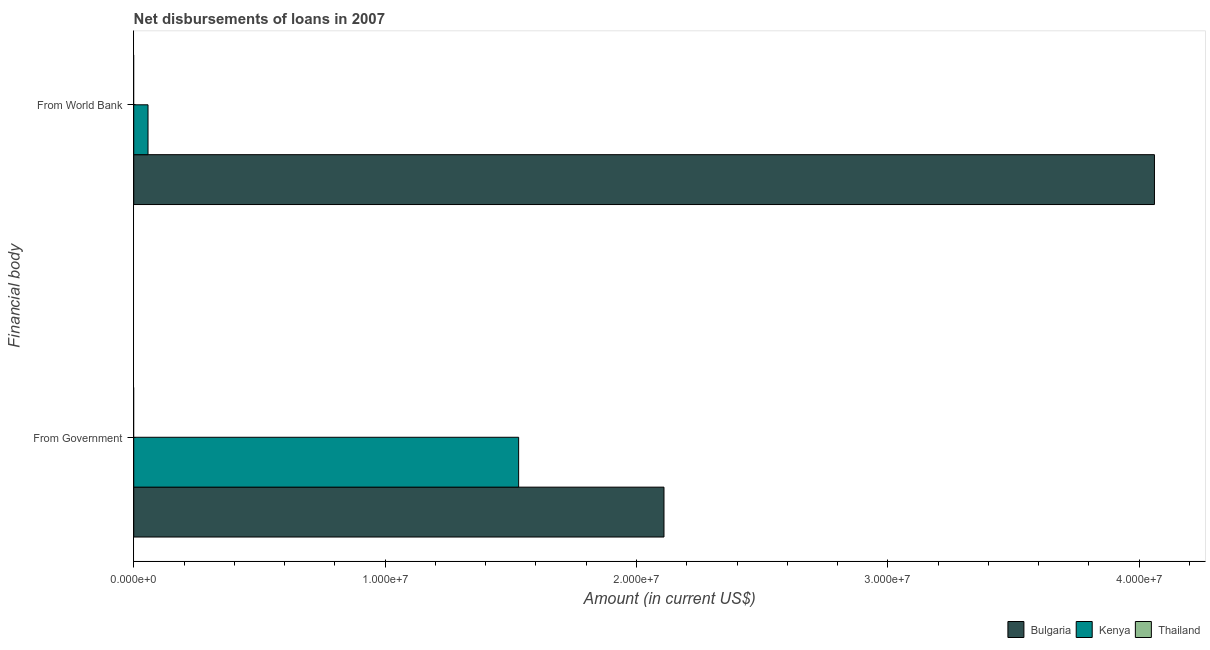How many groups of bars are there?
Make the answer very short. 2. Are the number of bars per tick equal to the number of legend labels?
Your answer should be very brief. No. Are the number of bars on each tick of the Y-axis equal?
Provide a short and direct response. Yes. What is the label of the 2nd group of bars from the top?
Your answer should be compact. From Government. What is the net disbursements of loan from government in Bulgaria?
Give a very brief answer. 2.11e+07. Across all countries, what is the maximum net disbursements of loan from government?
Give a very brief answer. 2.11e+07. What is the total net disbursements of loan from government in the graph?
Provide a short and direct response. 3.64e+07. What is the difference between the net disbursements of loan from world bank in Kenya and that in Bulgaria?
Offer a terse response. -4.00e+07. What is the difference between the net disbursements of loan from government in Bulgaria and the net disbursements of loan from world bank in Kenya?
Your answer should be compact. 2.05e+07. What is the average net disbursements of loan from world bank per country?
Provide a short and direct response. 1.37e+07. What is the difference between the net disbursements of loan from government and net disbursements of loan from world bank in Bulgaria?
Your answer should be very brief. -1.95e+07. In how many countries, is the net disbursements of loan from world bank greater than 2000000 US$?
Provide a succinct answer. 1. What is the ratio of the net disbursements of loan from government in Kenya to that in Bulgaria?
Give a very brief answer. 0.73. Is the net disbursements of loan from government in Bulgaria less than that in Kenya?
Make the answer very short. No. How many bars are there?
Provide a succinct answer. 4. Are all the bars in the graph horizontal?
Offer a very short reply. Yes. Are the values on the major ticks of X-axis written in scientific E-notation?
Keep it short and to the point. Yes. Where does the legend appear in the graph?
Make the answer very short. Bottom right. How are the legend labels stacked?
Keep it short and to the point. Horizontal. What is the title of the graph?
Your answer should be very brief. Net disbursements of loans in 2007. Does "Kyrgyz Republic" appear as one of the legend labels in the graph?
Your answer should be very brief. No. What is the label or title of the Y-axis?
Offer a terse response. Financial body. What is the Amount (in current US$) in Bulgaria in From Government?
Offer a terse response. 2.11e+07. What is the Amount (in current US$) in Kenya in From Government?
Give a very brief answer. 1.53e+07. What is the Amount (in current US$) of Thailand in From Government?
Offer a very short reply. 0. What is the Amount (in current US$) of Bulgaria in From World Bank?
Your response must be concise. 4.06e+07. What is the Amount (in current US$) in Kenya in From World Bank?
Your answer should be very brief. 5.68e+05. Across all Financial body, what is the maximum Amount (in current US$) in Bulgaria?
Provide a succinct answer. 4.06e+07. Across all Financial body, what is the maximum Amount (in current US$) of Kenya?
Offer a very short reply. 1.53e+07. Across all Financial body, what is the minimum Amount (in current US$) of Bulgaria?
Offer a very short reply. 2.11e+07. Across all Financial body, what is the minimum Amount (in current US$) in Kenya?
Provide a succinct answer. 5.68e+05. What is the total Amount (in current US$) of Bulgaria in the graph?
Provide a short and direct response. 6.17e+07. What is the total Amount (in current US$) in Kenya in the graph?
Your answer should be compact. 1.59e+07. What is the total Amount (in current US$) of Thailand in the graph?
Provide a succinct answer. 0. What is the difference between the Amount (in current US$) of Bulgaria in From Government and that in From World Bank?
Offer a very short reply. -1.95e+07. What is the difference between the Amount (in current US$) of Kenya in From Government and that in From World Bank?
Your answer should be very brief. 1.47e+07. What is the difference between the Amount (in current US$) in Bulgaria in From Government and the Amount (in current US$) in Kenya in From World Bank?
Ensure brevity in your answer.  2.05e+07. What is the average Amount (in current US$) in Bulgaria per Financial body?
Your response must be concise. 3.09e+07. What is the average Amount (in current US$) of Kenya per Financial body?
Your answer should be compact. 7.94e+06. What is the difference between the Amount (in current US$) of Bulgaria and Amount (in current US$) of Kenya in From Government?
Offer a terse response. 5.78e+06. What is the difference between the Amount (in current US$) in Bulgaria and Amount (in current US$) in Kenya in From World Bank?
Your answer should be compact. 4.00e+07. What is the ratio of the Amount (in current US$) in Bulgaria in From Government to that in From World Bank?
Your answer should be very brief. 0.52. What is the ratio of the Amount (in current US$) of Kenya in From Government to that in From World Bank?
Make the answer very short. 26.96. What is the difference between the highest and the second highest Amount (in current US$) in Bulgaria?
Make the answer very short. 1.95e+07. What is the difference between the highest and the second highest Amount (in current US$) of Kenya?
Make the answer very short. 1.47e+07. What is the difference between the highest and the lowest Amount (in current US$) in Bulgaria?
Your response must be concise. 1.95e+07. What is the difference between the highest and the lowest Amount (in current US$) of Kenya?
Your answer should be compact. 1.47e+07. 